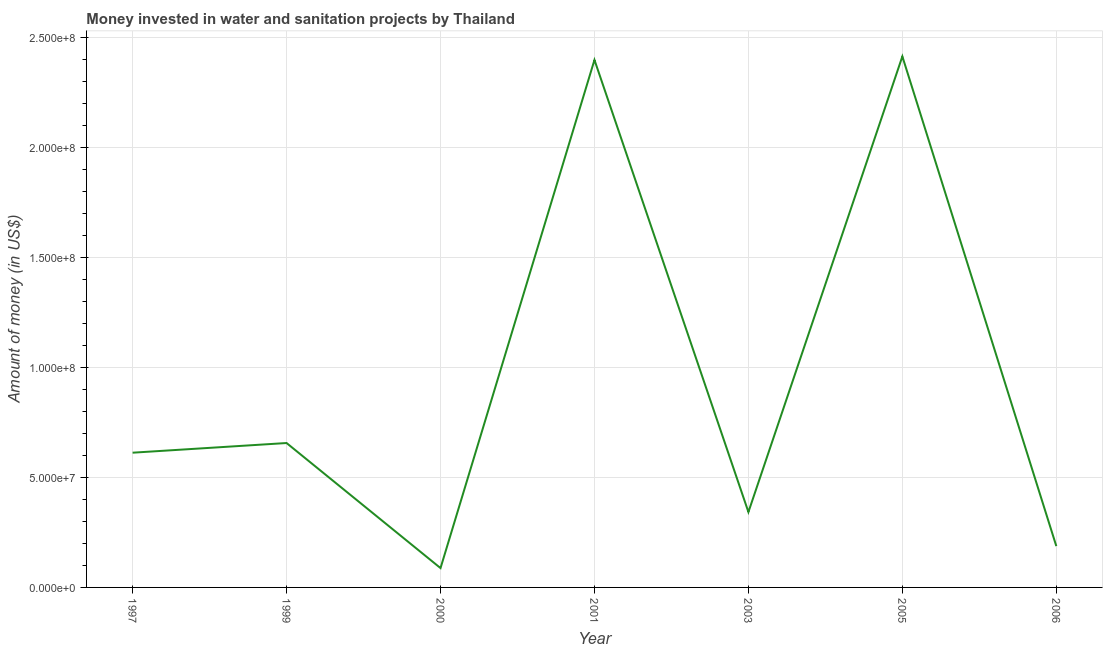What is the investment in 2000?
Ensure brevity in your answer.  8.80e+06. Across all years, what is the maximum investment?
Your response must be concise. 2.42e+08. Across all years, what is the minimum investment?
Your answer should be compact. 8.80e+06. In which year was the investment minimum?
Your answer should be compact. 2000. What is the sum of the investment?
Keep it short and to the point. 6.70e+08. What is the difference between the investment in 1997 and 2006?
Provide a succinct answer. 4.25e+07. What is the average investment per year?
Offer a terse response. 9.58e+07. What is the median investment?
Provide a succinct answer. 6.13e+07. In how many years, is the investment greater than 110000000 US$?
Your response must be concise. 2. Do a majority of the years between 2006 and 2000 (inclusive) have investment greater than 230000000 US$?
Keep it short and to the point. Yes. What is the ratio of the investment in 1997 to that in 2000?
Offer a terse response. 6.97. What is the difference between the highest and the second highest investment?
Ensure brevity in your answer.  1.60e+06. What is the difference between the highest and the lowest investment?
Provide a short and direct response. 2.33e+08. In how many years, is the investment greater than the average investment taken over all years?
Make the answer very short. 2. Does the investment monotonically increase over the years?
Ensure brevity in your answer.  No. How many years are there in the graph?
Give a very brief answer. 7. What is the title of the graph?
Your answer should be very brief. Money invested in water and sanitation projects by Thailand. What is the label or title of the X-axis?
Offer a very short reply. Year. What is the label or title of the Y-axis?
Offer a very short reply. Amount of money (in US$). What is the Amount of money (in US$) of 1997?
Ensure brevity in your answer.  6.13e+07. What is the Amount of money (in US$) in 1999?
Keep it short and to the point. 6.57e+07. What is the Amount of money (in US$) of 2000?
Your answer should be very brief. 8.80e+06. What is the Amount of money (in US$) in 2001?
Give a very brief answer. 2.40e+08. What is the Amount of money (in US$) of 2003?
Offer a very short reply. 3.43e+07. What is the Amount of money (in US$) in 2005?
Ensure brevity in your answer.  2.42e+08. What is the Amount of money (in US$) in 2006?
Offer a very short reply. 1.88e+07. What is the difference between the Amount of money (in US$) in 1997 and 1999?
Your response must be concise. -4.40e+06. What is the difference between the Amount of money (in US$) in 1997 and 2000?
Offer a very short reply. 5.25e+07. What is the difference between the Amount of money (in US$) in 1997 and 2001?
Ensure brevity in your answer.  -1.79e+08. What is the difference between the Amount of money (in US$) in 1997 and 2003?
Provide a succinct answer. 2.70e+07. What is the difference between the Amount of money (in US$) in 1997 and 2005?
Offer a very short reply. -1.80e+08. What is the difference between the Amount of money (in US$) in 1997 and 2006?
Give a very brief answer. 4.25e+07. What is the difference between the Amount of money (in US$) in 1999 and 2000?
Offer a terse response. 5.69e+07. What is the difference between the Amount of money (in US$) in 1999 and 2001?
Provide a succinct answer. -1.74e+08. What is the difference between the Amount of money (in US$) in 1999 and 2003?
Make the answer very short. 3.14e+07. What is the difference between the Amount of money (in US$) in 1999 and 2005?
Give a very brief answer. -1.76e+08. What is the difference between the Amount of money (in US$) in 1999 and 2006?
Your answer should be compact. 4.69e+07. What is the difference between the Amount of money (in US$) in 2000 and 2001?
Give a very brief answer. -2.31e+08. What is the difference between the Amount of money (in US$) in 2000 and 2003?
Make the answer very short. -2.55e+07. What is the difference between the Amount of money (in US$) in 2000 and 2005?
Make the answer very short. -2.33e+08. What is the difference between the Amount of money (in US$) in 2000 and 2006?
Provide a succinct answer. -1.00e+07. What is the difference between the Amount of money (in US$) in 2001 and 2003?
Your response must be concise. 2.06e+08. What is the difference between the Amount of money (in US$) in 2001 and 2005?
Your answer should be compact. -1.60e+06. What is the difference between the Amount of money (in US$) in 2001 and 2006?
Offer a very short reply. 2.21e+08. What is the difference between the Amount of money (in US$) in 2003 and 2005?
Offer a very short reply. -2.07e+08. What is the difference between the Amount of money (in US$) in 2003 and 2006?
Provide a succinct answer. 1.55e+07. What is the difference between the Amount of money (in US$) in 2005 and 2006?
Keep it short and to the point. 2.23e+08. What is the ratio of the Amount of money (in US$) in 1997 to that in 1999?
Give a very brief answer. 0.93. What is the ratio of the Amount of money (in US$) in 1997 to that in 2000?
Your answer should be compact. 6.97. What is the ratio of the Amount of money (in US$) in 1997 to that in 2001?
Ensure brevity in your answer.  0.26. What is the ratio of the Amount of money (in US$) in 1997 to that in 2003?
Give a very brief answer. 1.79. What is the ratio of the Amount of money (in US$) in 1997 to that in 2005?
Offer a terse response. 0.25. What is the ratio of the Amount of money (in US$) in 1997 to that in 2006?
Give a very brief answer. 3.26. What is the ratio of the Amount of money (in US$) in 1999 to that in 2000?
Your response must be concise. 7.47. What is the ratio of the Amount of money (in US$) in 1999 to that in 2001?
Your answer should be compact. 0.27. What is the ratio of the Amount of money (in US$) in 1999 to that in 2003?
Make the answer very short. 1.92. What is the ratio of the Amount of money (in US$) in 1999 to that in 2005?
Ensure brevity in your answer.  0.27. What is the ratio of the Amount of money (in US$) in 1999 to that in 2006?
Provide a succinct answer. 3.5. What is the ratio of the Amount of money (in US$) in 2000 to that in 2001?
Keep it short and to the point. 0.04. What is the ratio of the Amount of money (in US$) in 2000 to that in 2003?
Provide a succinct answer. 0.26. What is the ratio of the Amount of money (in US$) in 2000 to that in 2005?
Your response must be concise. 0.04. What is the ratio of the Amount of money (in US$) in 2000 to that in 2006?
Your response must be concise. 0.47. What is the ratio of the Amount of money (in US$) in 2001 to that in 2003?
Give a very brief answer. 7. What is the ratio of the Amount of money (in US$) in 2001 to that in 2005?
Make the answer very short. 0.99. What is the ratio of the Amount of money (in US$) in 2001 to that in 2006?
Provide a short and direct response. 12.77. What is the ratio of the Amount of money (in US$) in 2003 to that in 2005?
Provide a succinct answer. 0.14. What is the ratio of the Amount of money (in US$) in 2003 to that in 2006?
Your answer should be compact. 1.82. What is the ratio of the Amount of money (in US$) in 2005 to that in 2006?
Your response must be concise. 12.85. 